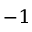<formula> <loc_0><loc_0><loc_500><loc_500>^ { - 1 }</formula> 